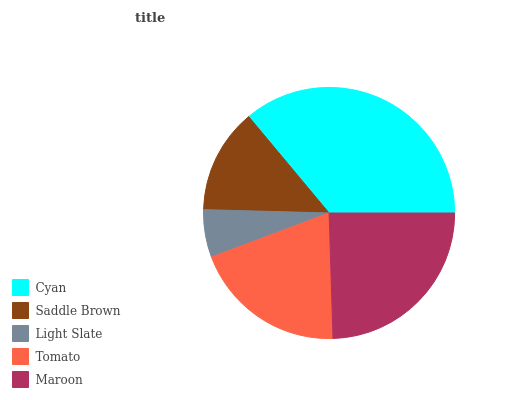Is Light Slate the minimum?
Answer yes or no. Yes. Is Cyan the maximum?
Answer yes or no. Yes. Is Saddle Brown the minimum?
Answer yes or no. No. Is Saddle Brown the maximum?
Answer yes or no. No. Is Cyan greater than Saddle Brown?
Answer yes or no. Yes. Is Saddle Brown less than Cyan?
Answer yes or no. Yes. Is Saddle Brown greater than Cyan?
Answer yes or no. No. Is Cyan less than Saddle Brown?
Answer yes or no. No. Is Tomato the high median?
Answer yes or no. Yes. Is Tomato the low median?
Answer yes or no. Yes. Is Saddle Brown the high median?
Answer yes or no. No. Is Cyan the low median?
Answer yes or no. No. 